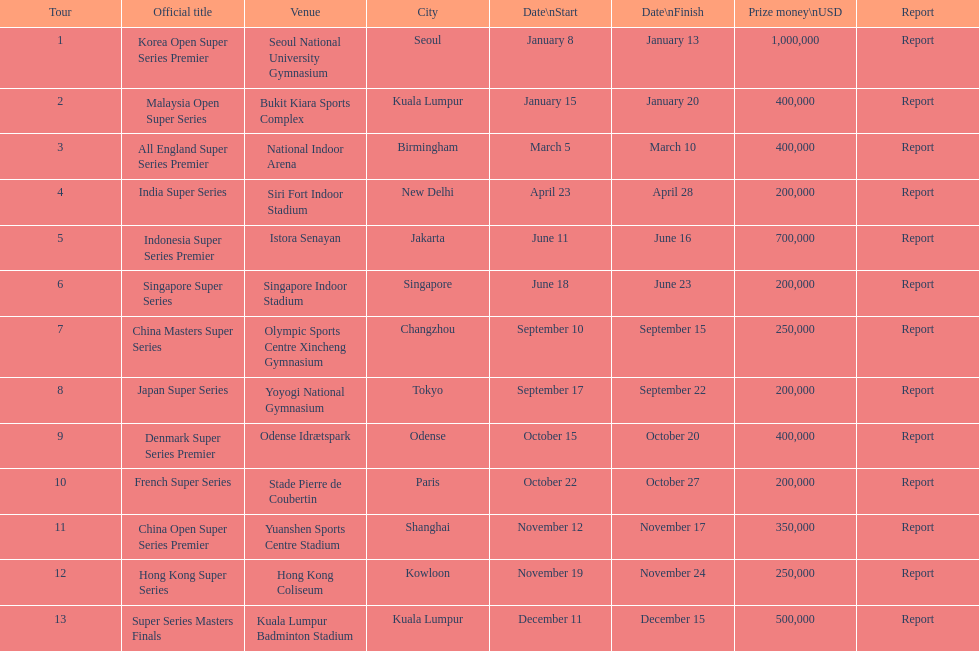Which series has the highest prize payout? Korea Open Super Series Premier. 